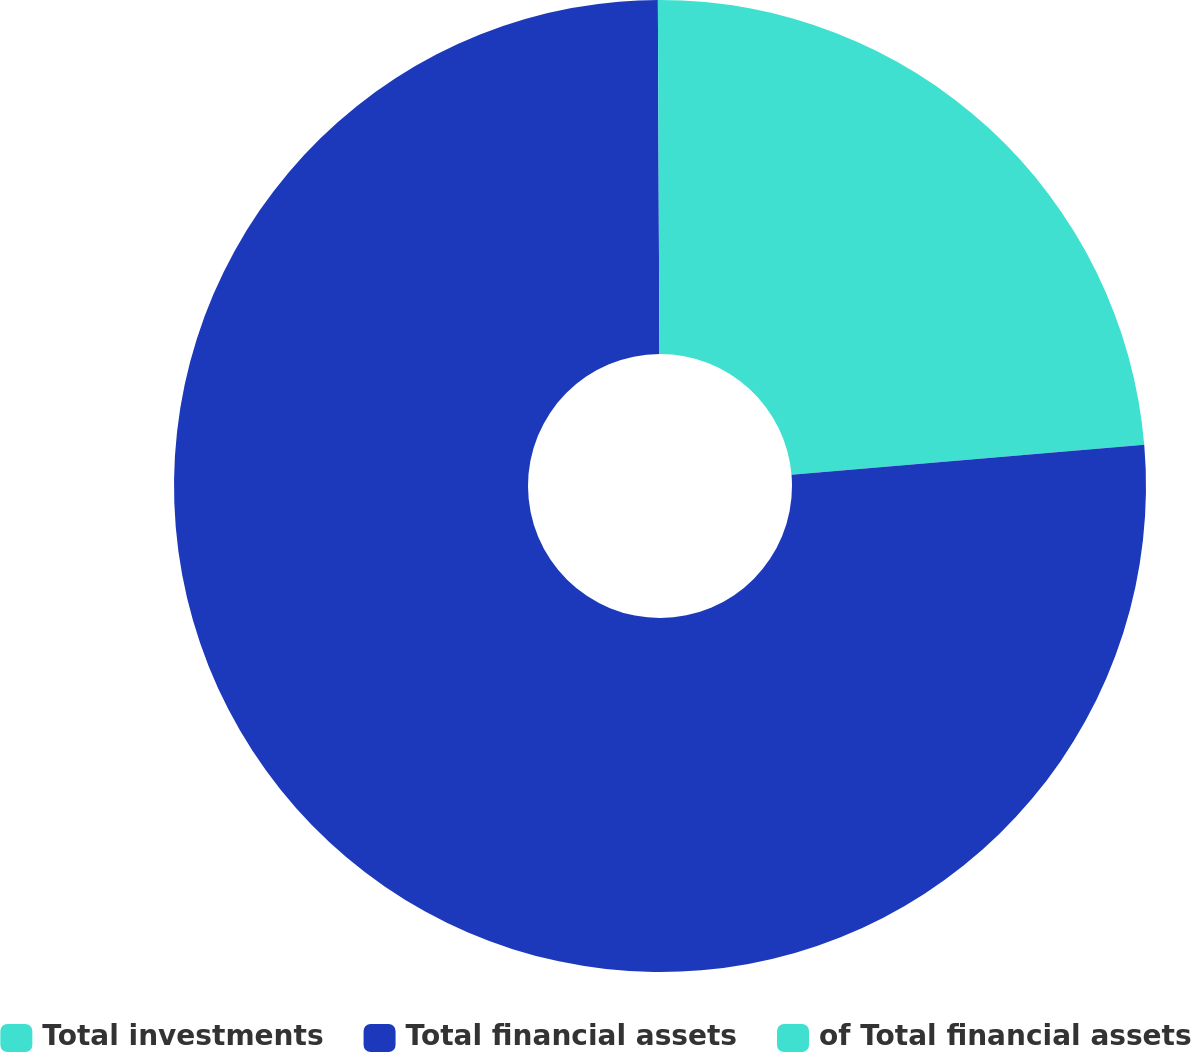Convert chart. <chart><loc_0><loc_0><loc_500><loc_500><pie_chart><fcel>Total investments<fcel>Total financial assets<fcel>of Total financial assets<nl><fcel>23.65%<fcel>76.28%<fcel>0.07%<nl></chart> 